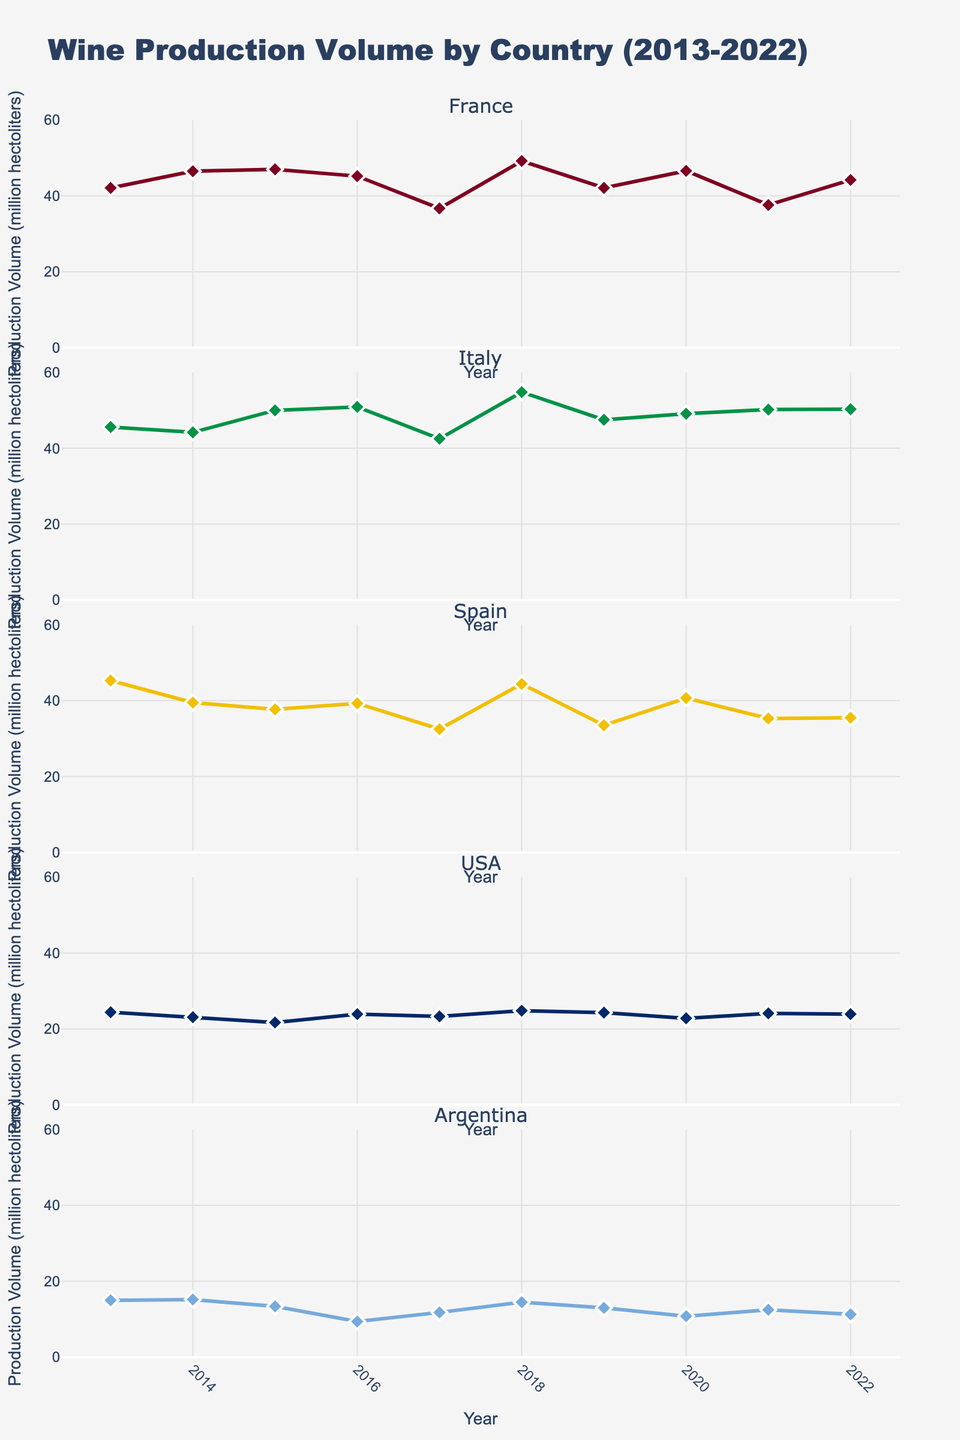How many countries are shown in the figure? The figure shows five individual vertical subplots, each representing a different country.
Answer: Five Which country had the highest wine production volume in 2022? By looking at the last data point on the subplot for each country, Italy's subplot shows the highest production volume in 2022.
Answer: Italy What is the overall trend in wine production in France from 2013 to 2022? Observing the plot for France from 2013 to 2022, there are fluctuations, but no consistent increase or decrease.
Answer: Fluctuating Which country experienced the largest decline in production from 2018 to 2019? By comparing the slopes of the lines between 2018 and 2019 across all subplots, Spain shows the steepest decline.
Answer: Spain What was the production volume difference for the USA between 2014 and 2015? The production volume for the USA in 2014 was 23.1 million hectoliters and 21.7 million hectoliters in 2015. The difference is 23.1 - 21.7 = 1.4.
Answer: 1.4 million hectoliters Which two countries had the closest production volumes in 2019? Looking at the 2019 data points for all countries, France and USA had very close production volumes of 42.1 and 24.3 million hectoliters, respectively.
Answer: France and USA Which year had the highest average production volume across all countries? Calculating the average production volume for each year and comparing, 2018 had the highest average.
Answer: 2018 What has been the trend for Argentina's wine production from 2015 to 2022? Observing Argentina’s subplot from 2015 to 2022, there is a general declining trend with minor fluctuations.
Answer: Declining How did Italy's wine production volume change from 2016 to 2017? Italy's wine production volume decreased from 50.9 million hectoliters in 2016 to 42.5 million hectoliters in 2017.
Answer: Decreased Which country showed the most consistent production volume pattern over the years shown? Observing all subplots, the USA shows the most consistent pattern with relatively minor fluctuations each year.
Answer: USA 